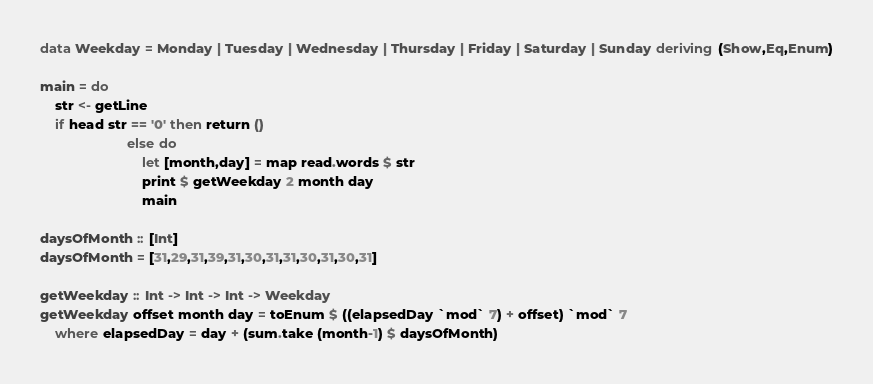<code> <loc_0><loc_0><loc_500><loc_500><_Haskell_>data Weekday = Monday | Tuesday | Wednesday | Thursday | Friday | Saturday | Sunday deriving (Show,Eq,Enum)

main = do
    str <- getLine
    if head str == '0' then return ()
                       else do
                           let [month,day] = map read.words $ str
                           print $ getWeekday 2 month day
                           main

daysOfMonth :: [Int]
daysOfMonth = [31,29,31,39,31,30,31,31,30,31,30,31]

getWeekday :: Int -> Int -> Int -> Weekday
getWeekday offset month day = toEnum $ ((elapsedDay `mod` 7) + offset) `mod` 7
    where elapsedDay = day + (sum.take (month-1) $ daysOfMonth)</code> 